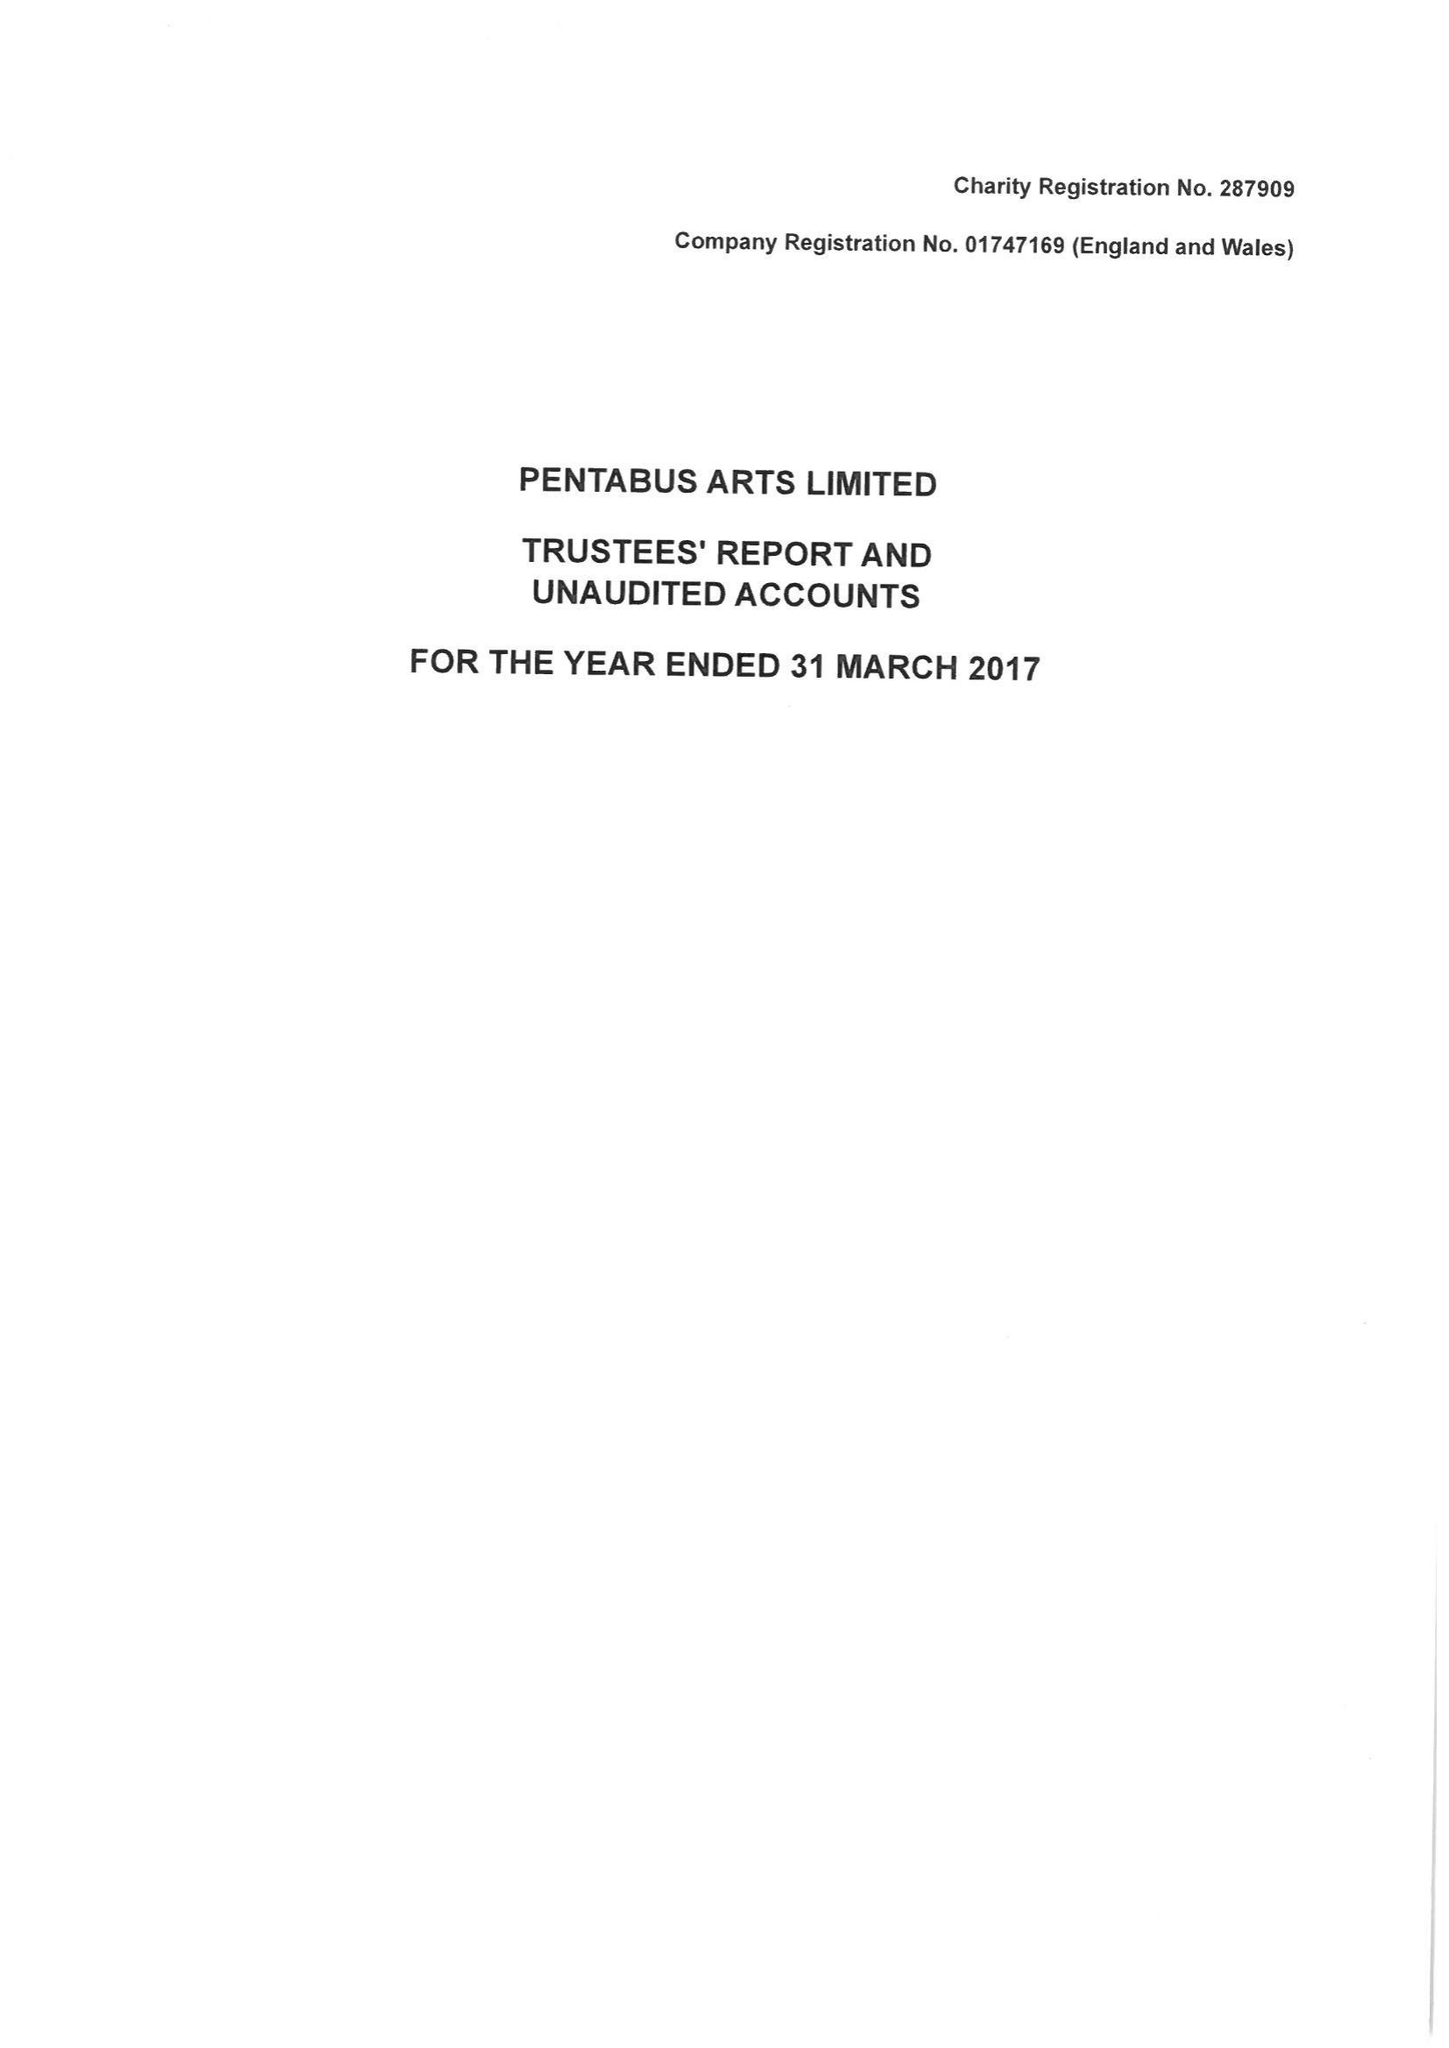What is the value for the address__post_town?
Answer the question using a single word or phrase. LUDLOW 